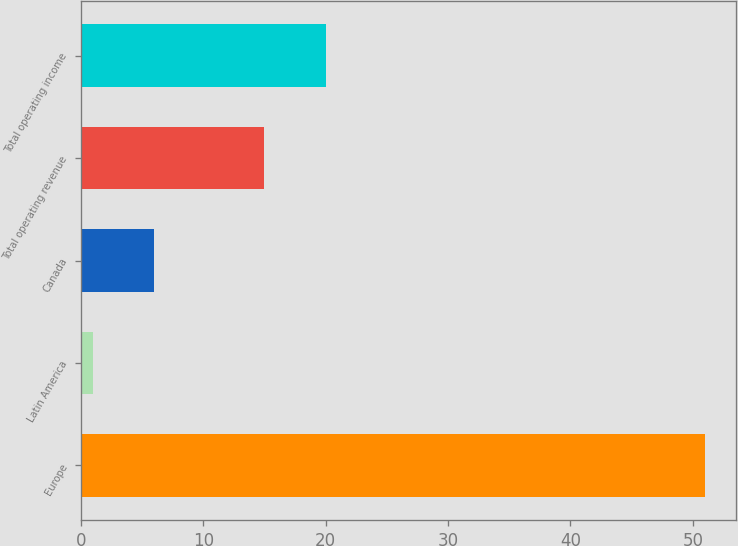<chart> <loc_0><loc_0><loc_500><loc_500><bar_chart><fcel>Europe<fcel>Latin America<fcel>Canada<fcel>Total operating revenue<fcel>Total operating income<nl><fcel>51<fcel>1<fcel>6<fcel>15<fcel>20<nl></chart> 